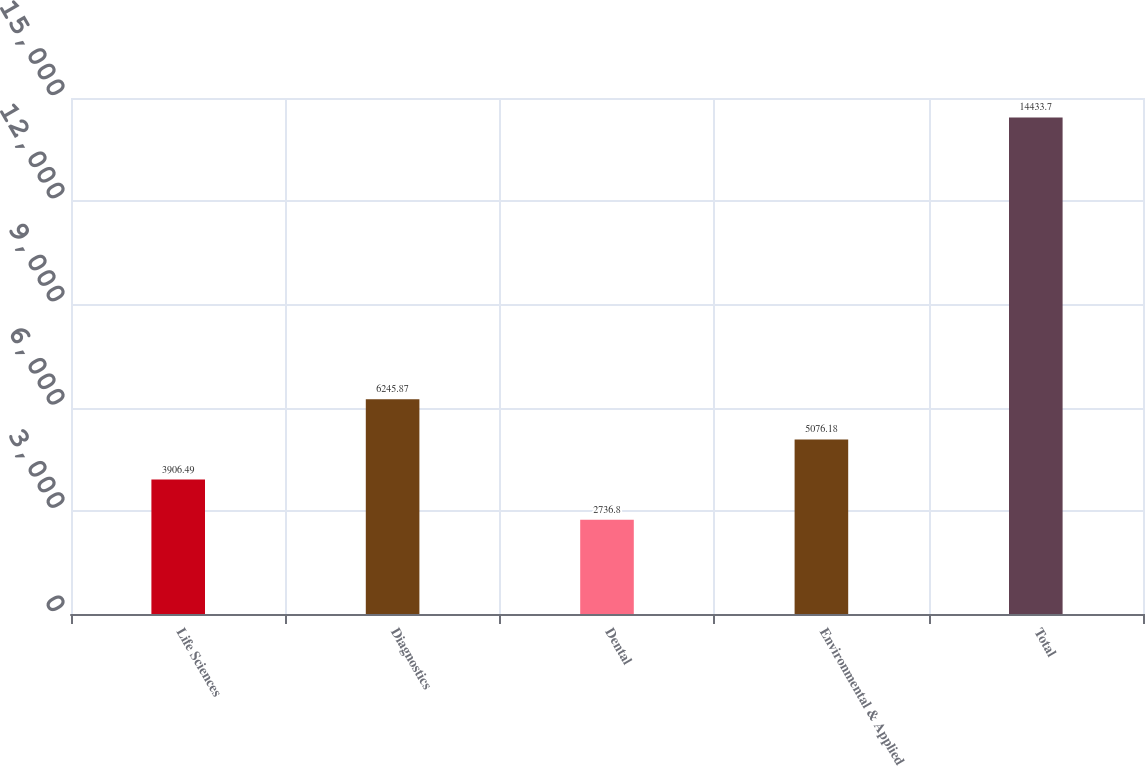<chart> <loc_0><loc_0><loc_500><loc_500><bar_chart><fcel>Life Sciences<fcel>Diagnostics<fcel>Dental<fcel>Environmental & Applied<fcel>Total<nl><fcel>3906.49<fcel>6245.87<fcel>2736.8<fcel>5076.18<fcel>14433.7<nl></chart> 